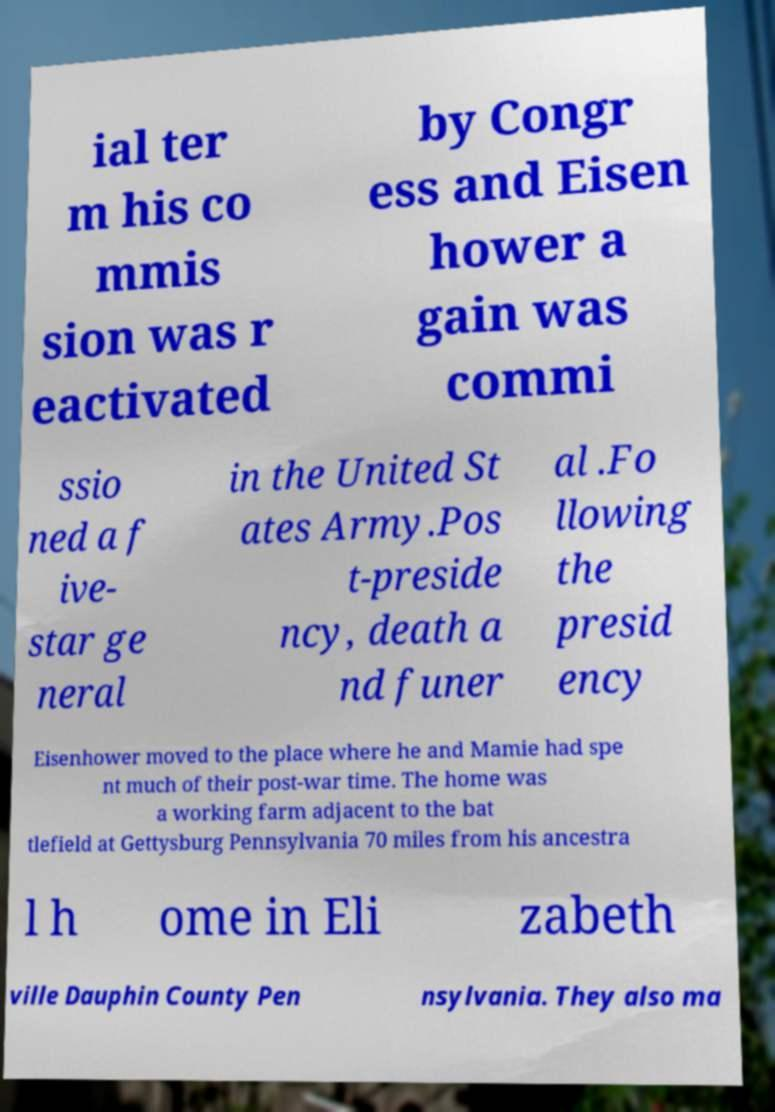Can you accurately transcribe the text from the provided image for me? ial ter m his co mmis sion was r eactivated by Congr ess and Eisen hower a gain was commi ssio ned a f ive- star ge neral in the United St ates Army.Pos t-preside ncy, death a nd funer al .Fo llowing the presid ency Eisenhower moved to the place where he and Mamie had spe nt much of their post-war time. The home was a working farm adjacent to the bat tlefield at Gettysburg Pennsylvania 70 miles from his ancestra l h ome in Eli zabeth ville Dauphin County Pen nsylvania. They also ma 